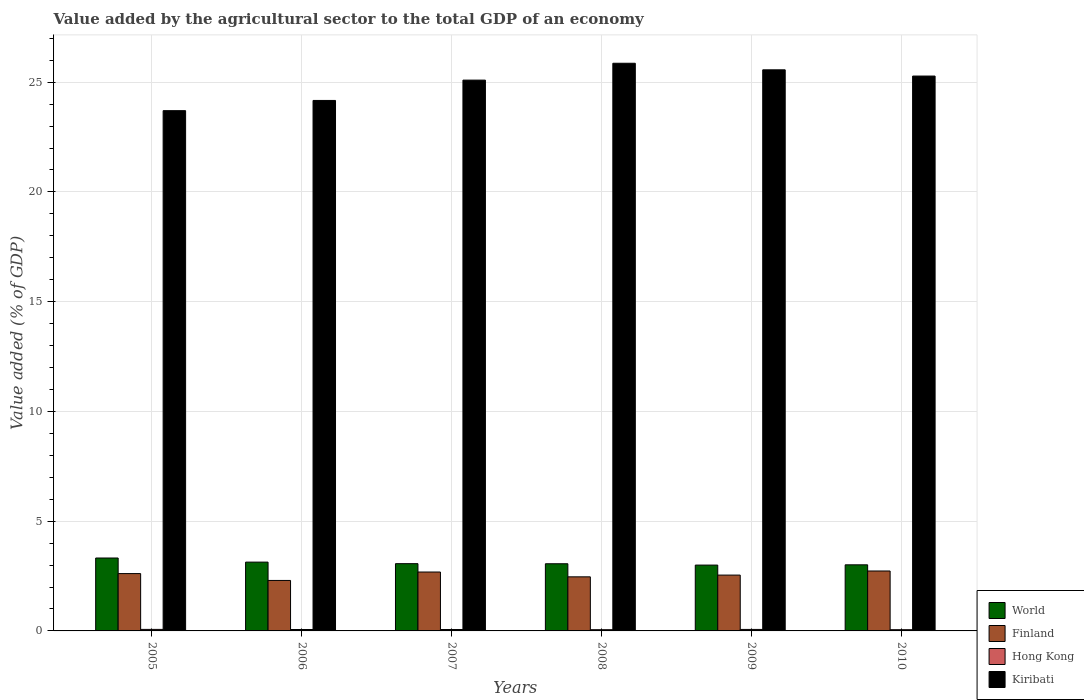How many different coloured bars are there?
Your answer should be very brief. 4. How many groups of bars are there?
Give a very brief answer. 6. Are the number of bars per tick equal to the number of legend labels?
Your answer should be very brief. Yes. Are the number of bars on each tick of the X-axis equal?
Your answer should be very brief. Yes. How many bars are there on the 2nd tick from the right?
Ensure brevity in your answer.  4. What is the label of the 4th group of bars from the left?
Provide a short and direct response. 2008. What is the value added by the agricultural sector to the total GDP in Kiribati in 2006?
Your answer should be compact. 24.17. Across all years, what is the maximum value added by the agricultural sector to the total GDP in Kiribati?
Your response must be concise. 25.86. Across all years, what is the minimum value added by the agricultural sector to the total GDP in Kiribati?
Offer a very short reply. 23.7. In which year was the value added by the agricultural sector to the total GDP in Kiribati minimum?
Provide a short and direct response. 2005. What is the total value added by the agricultural sector to the total GDP in Finland in the graph?
Keep it short and to the point. 15.33. What is the difference between the value added by the agricultural sector to the total GDP in Finland in 2005 and that in 2008?
Provide a short and direct response. 0.15. What is the difference between the value added by the agricultural sector to the total GDP in Finland in 2008 and the value added by the agricultural sector to the total GDP in World in 2007?
Your response must be concise. -0.6. What is the average value added by the agricultural sector to the total GDP in Hong Kong per year?
Offer a terse response. 0.06. In the year 2005, what is the difference between the value added by the agricultural sector to the total GDP in Hong Kong and value added by the agricultural sector to the total GDP in Kiribati?
Offer a very short reply. -23.63. In how many years, is the value added by the agricultural sector to the total GDP in Hong Kong greater than 23 %?
Ensure brevity in your answer.  0. What is the ratio of the value added by the agricultural sector to the total GDP in Kiribati in 2005 to that in 2006?
Your answer should be very brief. 0.98. Is the difference between the value added by the agricultural sector to the total GDP in Hong Kong in 2006 and 2008 greater than the difference between the value added by the agricultural sector to the total GDP in Kiribati in 2006 and 2008?
Make the answer very short. Yes. What is the difference between the highest and the second highest value added by the agricultural sector to the total GDP in Hong Kong?
Your response must be concise. 0. What is the difference between the highest and the lowest value added by the agricultural sector to the total GDP in Kiribati?
Give a very brief answer. 2.16. In how many years, is the value added by the agricultural sector to the total GDP in Hong Kong greater than the average value added by the agricultural sector to the total GDP in Hong Kong taken over all years?
Give a very brief answer. 4. Is the sum of the value added by the agricultural sector to the total GDP in World in 2008 and 2009 greater than the maximum value added by the agricultural sector to the total GDP in Kiribati across all years?
Offer a terse response. No. What does the 3rd bar from the left in 2010 represents?
Give a very brief answer. Hong Kong. What does the 4th bar from the right in 2007 represents?
Provide a short and direct response. World. Are all the bars in the graph horizontal?
Make the answer very short. No. What is the difference between two consecutive major ticks on the Y-axis?
Give a very brief answer. 5. Are the values on the major ticks of Y-axis written in scientific E-notation?
Make the answer very short. No. Does the graph contain grids?
Offer a very short reply. Yes. How are the legend labels stacked?
Offer a very short reply. Vertical. What is the title of the graph?
Your response must be concise. Value added by the agricultural sector to the total GDP of an economy. What is the label or title of the Y-axis?
Your response must be concise. Value added (% of GDP). What is the Value added (% of GDP) of World in 2005?
Keep it short and to the point. 3.32. What is the Value added (% of GDP) in Finland in 2005?
Offer a very short reply. 2.61. What is the Value added (% of GDP) in Hong Kong in 2005?
Offer a terse response. 0.07. What is the Value added (% of GDP) of Kiribati in 2005?
Ensure brevity in your answer.  23.7. What is the Value added (% of GDP) in World in 2006?
Make the answer very short. 3.13. What is the Value added (% of GDP) of Finland in 2006?
Your answer should be very brief. 2.3. What is the Value added (% of GDP) of Hong Kong in 2006?
Provide a short and direct response. 0.06. What is the Value added (% of GDP) of Kiribati in 2006?
Your response must be concise. 24.17. What is the Value added (% of GDP) of World in 2007?
Offer a terse response. 3.06. What is the Value added (% of GDP) in Finland in 2007?
Your response must be concise. 2.68. What is the Value added (% of GDP) of Hong Kong in 2007?
Offer a terse response. 0.06. What is the Value added (% of GDP) of Kiribati in 2007?
Offer a very short reply. 25.09. What is the Value added (% of GDP) of World in 2008?
Make the answer very short. 3.06. What is the Value added (% of GDP) of Finland in 2008?
Your answer should be compact. 2.46. What is the Value added (% of GDP) in Hong Kong in 2008?
Your response must be concise. 0.06. What is the Value added (% of GDP) of Kiribati in 2008?
Give a very brief answer. 25.86. What is the Value added (% of GDP) in World in 2009?
Ensure brevity in your answer.  3. What is the Value added (% of GDP) of Finland in 2009?
Your answer should be compact. 2.54. What is the Value added (% of GDP) in Hong Kong in 2009?
Your response must be concise. 0.07. What is the Value added (% of GDP) of Kiribati in 2009?
Give a very brief answer. 25.56. What is the Value added (% of GDP) of World in 2010?
Offer a very short reply. 3.01. What is the Value added (% of GDP) of Finland in 2010?
Offer a terse response. 2.73. What is the Value added (% of GDP) of Hong Kong in 2010?
Make the answer very short. 0.06. What is the Value added (% of GDP) in Kiribati in 2010?
Your response must be concise. 25.28. Across all years, what is the maximum Value added (% of GDP) of World?
Make the answer very short. 3.32. Across all years, what is the maximum Value added (% of GDP) in Finland?
Offer a terse response. 2.73. Across all years, what is the maximum Value added (% of GDP) in Hong Kong?
Give a very brief answer. 0.07. Across all years, what is the maximum Value added (% of GDP) in Kiribati?
Provide a short and direct response. 25.86. Across all years, what is the minimum Value added (% of GDP) of World?
Make the answer very short. 3. Across all years, what is the minimum Value added (% of GDP) of Finland?
Offer a very short reply. 2.3. Across all years, what is the minimum Value added (% of GDP) in Hong Kong?
Keep it short and to the point. 0.06. Across all years, what is the minimum Value added (% of GDP) of Kiribati?
Offer a terse response. 23.7. What is the total Value added (% of GDP) in World in the graph?
Provide a short and direct response. 18.59. What is the total Value added (% of GDP) of Finland in the graph?
Your answer should be compact. 15.33. What is the total Value added (% of GDP) of Hong Kong in the graph?
Make the answer very short. 0.38. What is the total Value added (% of GDP) in Kiribati in the graph?
Provide a short and direct response. 149.67. What is the difference between the Value added (% of GDP) of World in 2005 and that in 2006?
Offer a very short reply. 0.19. What is the difference between the Value added (% of GDP) of Finland in 2005 and that in 2006?
Ensure brevity in your answer.  0.31. What is the difference between the Value added (% of GDP) of Hong Kong in 2005 and that in 2006?
Make the answer very short. 0. What is the difference between the Value added (% of GDP) in Kiribati in 2005 and that in 2006?
Your answer should be compact. -0.47. What is the difference between the Value added (% of GDP) in World in 2005 and that in 2007?
Your answer should be very brief. 0.26. What is the difference between the Value added (% of GDP) of Finland in 2005 and that in 2007?
Ensure brevity in your answer.  -0.07. What is the difference between the Value added (% of GDP) in Hong Kong in 2005 and that in 2007?
Your answer should be compact. 0.01. What is the difference between the Value added (% of GDP) in Kiribati in 2005 and that in 2007?
Provide a short and direct response. -1.39. What is the difference between the Value added (% of GDP) of World in 2005 and that in 2008?
Your answer should be very brief. 0.26. What is the difference between the Value added (% of GDP) in Finland in 2005 and that in 2008?
Make the answer very short. 0.15. What is the difference between the Value added (% of GDP) of Hong Kong in 2005 and that in 2008?
Make the answer very short. 0.01. What is the difference between the Value added (% of GDP) of Kiribati in 2005 and that in 2008?
Offer a very short reply. -2.16. What is the difference between the Value added (% of GDP) of World in 2005 and that in 2009?
Give a very brief answer. 0.32. What is the difference between the Value added (% of GDP) of Finland in 2005 and that in 2009?
Provide a short and direct response. 0.07. What is the difference between the Value added (% of GDP) in Hong Kong in 2005 and that in 2009?
Provide a succinct answer. 0. What is the difference between the Value added (% of GDP) in Kiribati in 2005 and that in 2009?
Offer a very short reply. -1.86. What is the difference between the Value added (% of GDP) of World in 2005 and that in 2010?
Make the answer very short. 0.31. What is the difference between the Value added (% of GDP) of Finland in 2005 and that in 2010?
Your response must be concise. -0.12. What is the difference between the Value added (% of GDP) in Hong Kong in 2005 and that in 2010?
Offer a very short reply. 0.01. What is the difference between the Value added (% of GDP) in Kiribati in 2005 and that in 2010?
Give a very brief answer. -1.58. What is the difference between the Value added (% of GDP) in World in 2006 and that in 2007?
Offer a terse response. 0.07. What is the difference between the Value added (% of GDP) of Finland in 2006 and that in 2007?
Keep it short and to the point. -0.38. What is the difference between the Value added (% of GDP) of Hong Kong in 2006 and that in 2007?
Keep it short and to the point. 0. What is the difference between the Value added (% of GDP) in Kiribati in 2006 and that in 2007?
Give a very brief answer. -0.93. What is the difference between the Value added (% of GDP) of World in 2006 and that in 2008?
Your response must be concise. 0.07. What is the difference between the Value added (% of GDP) in Finland in 2006 and that in 2008?
Provide a short and direct response. -0.16. What is the difference between the Value added (% of GDP) in Hong Kong in 2006 and that in 2008?
Your response must be concise. 0.01. What is the difference between the Value added (% of GDP) of Kiribati in 2006 and that in 2008?
Your answer should be compact. -1.69. What is the difference between the Value added (% of GDP) in World in 2006 and that in 2009?
Make the answer very short. 0.14. What is the difference between the Value added (% of GDP) of Finland in 2006 and that in 2009?
Your answer should be compact. -0.24. What is the difference between the Value added (% of GDP) of Hong Kong in 2006 and that in 2009?
Make the answer very short. -0. What is the difference between the Value added (% of GDP) of Kiribati in 2006 and that in 2009?
Your answer should be compact. -1.4. What is the difference between the Value added (% of GDP) of World in 2006 and that in 2010?
Provide a short and direct response. 0.12. What is the difference between the Value added (% of GDP) of Finland in 2006 and that in 2010?
Offer a terse response. -0.43. What is the difference between the Value added (% of GDP) in Hong Kong in 2006 and that in 2010?
Offer a very short reply. 0.01. What is the difference between the Value added (% of GDP) in Kiribati in 2006 and that in 2010?
Offer a terse response. -1.11. What is the difference between the Value added (% of GDP) of World in 2007 and that in 2008?
Your answer should be compact. 0. What is the difference between the Value added (% of GDP) in Finland in 2007 and that in 2008?
Make the answer very short. 0.22. What is the difference between the Value added (% of GDP) in Hong Kong in 2007 and that in 2008?
Ensure brevity in your answer.  0.01. What is the difference between the Value added (% of GDP) of Kiribati in 2007 and that in 2008?
Offer a terse response. -0.77. What is the difference between the Value added (% of GDP) of World in 2007 and that in 2009?
Offer a very short reply. 0.06. What is the difference between the Value added (% of GDP) in Finland in 2007 and that in 2009?
Offer a terse response. 0.14. What is the difference between the Value added (% of GDP) in Hong Kong in 2007 and that in 2009?
Your answer should be compact. -0. What is the difference between the Value added (% of GDP) in Kiribati in 2007 and that in 2009?
Offer a very short reply. -0.47. What is the difference between the Value added (% of GDP) in World in 2007 and that in 2010?
Offer a terse response. 0.05. What is the difference between the Value added (% of GDP) in Finland in 2007 and that in 2010?
Ensure brevity in your answer.  -0.05. What is the difference between the Value added (% of GDP) of Hong Kong in 2007 and that in 2010?
Offer a very short reply. 0.01. What is the difference between the Value added (% of GDP) of Kiribati in 2007 and that in 2010?
Keep it short and to the point. -0.19. What is the difference between the Value added (% of GDP) in World in 2008 and that in 2009?
Give a very brief answer. 0.06. What is the difference between the Value added (% of GDP) of Finland in 2008 and that in 2009?
Ensure brevity in your answer.  -0.08. What is the difference between the Value added (% of GDP) in Hong Kong in 2008 and that in 2009?
Make the answer very short. -0.01. What is the difference between the Value added (% of GDP) in Kiribati in 2008 and that in 2009?
Provide a succinct answer. 0.3. What is the difference between the Value added (% of GDP) of World in 2008 and that in 2010?
Your answer should be very brief. 0.05. What is the difference between the Value added (% of GDP) of Finland in 2008 and that in 2010?
Make the answer very short. -0.27. What is the difference between the Value added (% of GDP) in Hong Kong in 2008 and that in 2010?
Make the answer very short. 0. What is the difference between the Value added (% of GDP) in Kiribati in 2008 and that in 2010?
Offer a very short reply. 0.58. What is the difference between the Value added (% of GDP) of World in 2009 and that in 2010?
Keep it short and to the point. -0.01. What is the difference between the Value added (% of GDP) in Finland in 2009 and that in 2010?
Provide a short and direct response. -0.19. What is the difference between the Value added (% of GDP) in Hong Kong in 2009 and that in 2010?
Keep it short and to the point. 0.01. What is the difference between the Value added (% of GDP) of Kiribati in 2009 and that in 2010?
Keep it short and to the point. 0.28. What is the difference between the Value added (% of GDP) of World in 2005 and the Value added (% of GDP) of Finland in 2006?
Provide a succinct answer. 1.02. What is the difference between the Value added (% of GDP) of World in 2005 and the Value added (% of GDP) of Hong Kong in 2006?
Give a very brief answer. 3.26. What is the difference between the Value added (% of GDP) in World in 2005 and the Value added (% of GDP) in Kiribati in 2006?
Your answer should be compact. -20.85. What is the difference between the Value added (% of GDP) of Finland in 2005 and the Value added (% of GDP) of Hong Kong in 2006?
Provide a succinct answer. 2.55. What is the difference between the Value added (% of GDP) of Finland in 2005 and the Value added (% of GDP) of Kiribati in 2006?
Your answer should be very brief. -21.56. What is the difference between the Value added (% of GDP) in Hong Kong in 2005 and the Value added (% of GDP) in Kiribati in 2006?
Your answer should be compact. -24.1. What is the difference between the Value added (% of GDP) of World in 2005 and the Value added (% of GDP) of Finland in 2007?
Your response must be concise. 0.64. What is the difference between the Value added (% of GDP) in World in 2005 and the Value added (% of GDP) in Hong Kong in 2007?
Offer a very short reply. 3.26. What is the difference between the Value added (% of GDP) in World in 2005 and the Value added (% of GDP) in Kiribati in 2007?
Make the answer very short. -21.77. What is the difference between the Value added (% of GDP) in Finland in 2005 and the Value added (% of GDP) in Hong Kong in 2007?
Give a very brief answer. 2.55. What is the difference between the Value added (% of GDP) of Finland in 2005 and the Value added (% of GDP) of Kiribati in 2007?
Make the answer very short. -22.48. What is the difference between the Value added (% of GDP) in Hong Kong in 2005 and the Value added (% of GDP) in Kiribati in 2007?
Keep it short and to the point. -25.03. What is the difference between the Value added (% of GDP) in World in 2005 and the Value added (% of GDP) in Finland in 2008?
Offer a very short reply. 0.86. What is the difference between the Value added (% of GDP) of World in 2005 and the Value added (% of GDP) of Hong Kong in 2008?
Provide a succinct answer. 3.27. What is the difference between the Value added (% of GDP) in World in 2005 and the Value added (% of GDP) in Kiribati in 2008?
Provide a short and direct response. -22.54. What is the difference between the Value added (% of GDP) in Finland in 2005 and the Value added (% of GDP) in Hong Kong in 2008?
Keep it short and to the point. 2.56. What is the difference between the Value added (% of GDP) in Finland in 2005 and the Value added (% of GDP) in Kiribati in 2008?
Make the answer very short. -23.25. What is the difference between the Value added (% of GDP) in Hong Kong in 2005 and the Value added (% of GDP) in Kiribati in 2008?
Your answer should be very brief. -25.79. What is the difference between the Value added (% of GDP) of World in 2005 and the Value added (% of GDP) of Finland in 2009?
Keep it short and to the point. 0.78. What is the difference between the Value added (% of GDP) of World in 2005 and the Value added (% of GDP) of Hong Kong in 2009?
Keep it short and to the point. 3.25. What is the difference between the Value added (% of GDP) of World in 2005 and the Value added (% of GDP) of Kiribati in 2009?
Offer a very short reply. -22.24. What is the difference between the Value added (% of GDP) of Finland in 2005 and the Value added (% of GDP) of Hong Kong in 2009?
Offer a very short reply. 2.54. What is the difference between the Value added (% of GDP) of Finland in 2005 and the Value added (% of GDP) of Kiribati in 2009?
Provide a succinct answer. -22.95. What is the difference between the Value added (% of GDP) in Hong Kong in 2005 and the Value added (% of GDP) in Kiribati in 2009?
Make the answer very short. -25.49. What is the difference between the Value added (% of GDP) in World in 2005 and the Value added (% of GDP) in Finland in 2010?
Offer a very short reply. 0.59. What is the difference between the Value added (% of GDP) in World in 2005 and the Value added (% of GDP) in Hong Kong in 2010?
Ensure brevity in your answer.  3.27. What is the difference between the Value added (% of GDP) in World in 2005 and the Value added (% of GDP) in Kiribati in 2010?
Provide a succinct answer. -21.96. What is the difference between the Value added (% of GDP) in Finland in 2005 and the Value added (% of GDP) in Hong Kong in 2010?
Provide a short and direct response. 2.56. What is the difference between the Value added (% of GDP) in Finland in 2005 and the Value added (% of GDP) in Kiribati in 2010?
Your response must be concise. -22.67. What is the difference between the Value added (% of GDP) of Hong Kong in 2005 and the Value added (% of GDP) of Kiribati in 2010?
Provide a succinct answer. -25.21. What is the difference between the Value added (% of GDP) of World in 2006 and the Value added (% of GDP) of Finland in 2007?
Your answer should be very brief. 0.45. What is the difference between the Value added (% of GDP) in World in 2006 and the Value added (% of GDP) in Hong Kong in 2007?
Give a very brief answer. 3.07. What is the difference between the Value added (% of GDP) in World in 2006 and the Value added (% of GDP) in Kiribati in 2007?
Your response must be concise. -21.96. What is the difference between the Value added (% of GDP) of Finland in 2006 and the Value added (% of GDP) of Hong Kong in 2007?
Your response must be concise. 2.24. What is the difference between the Value added (% of GDP) in Finland in 2006 and the Value added (% of GDP) in Kiribati in 2007?
Keep it short and to the point. -22.8. What is the difference between the Value added (% of GDP) of Hong Kong in 2006 and the Value added (% of GDP) of Kiribati in 2007?
Give a very brief answer. -25.03. What is the difference between the Value added (% of GDP) of World in 2006 and the Value added (% of GDP) of Finland in 2008?
Offer a very short reply. 0.67. What is the difference between the Value added (% of GDP) of World in 2006 and the Value added (% of GDP) of Hong Kong in 2008?
Your answer should be very brief. 3.08. What is the difference between the Value added (% of GDP) in World in 2006 and the Value added (% of GDP) in Kiribati in 2008?
Ensure brevity in your answer.  -22.73. What is the difference between the Value added (% of GDP) in Finland in 2006 and the Value added (% of GDP) in Hong Kong in 2008?
Make the answer very short. 2.24. What is the difference between the Value added (% of GDP) of Finland in 2006 and the Value added (% of GDP) of Kiribati in 2008?
Provide a short and direct response. -23.56. What is the difference between the Value added (% of GDP) in Hong Kong in 2006 and the Value added (% of GDP) in Kiribati in 2008?
Give a very brief answer. -25.8. What is the difference between the Value added (% of GDP) in World in 2006 and the Value added (% of GDP) in Finland in 2009?
Your answer should be compact. 0.59. What is the difference between the Value added (% of GDP) of World in 2006 and the Value added (% of GDP) of Hong Kong in 2009?
Offer a very short reply. 3.07. What is the difference between the Value added (% of GDP) of World in 2006 and the Value added (% of GDP) of Kiribati in 2009?
Your answer should be compact. -22.43. What is the difference between the Value added (% of GDP) of Finland in 2006 and the Value added (% of GDP) of Hong Kong in 2009?
Your response must be concise. 2.23. What is the difference between the Value added (% of GDP) in Finland in 2006 and the Value added (% of GDP) in Kiribati in 2009?
Keep it short and to the point. -23.26. What is the difference between the Value added (% of GDP) in Hong Kong in 2006 and the Value added (% of GDP) in Kiribati in 2009?
Provide a short and direct response. -25.5. What is the difference between the Value added (% of GDP) in World in 2006 and the Value added (% of GDP) in Finland in 2010?
Provide a short and direct response. 0.4. What is the difference between the Value added (% of GDP) of World in 2006 and the Value added (% of GDP) of Hong Kong in 2010?
Offer a very short reply. 3.08. What is the difference between the Value added (% of GDP) in World in 2006 and the Value added (% of GDP) in Kiribati in 2010?
Your answer should be compact. -22.14. What is the difference between the Value added (% of GDP) of Finland in 2006 and the Value added (% of GDP) of Hong Kong in 2010?
Your response must be concise. 2.24. What is the difference between the Value added (% of GDP) in Finland in 2006 and the Value added (% of GDP) in Kiribati in 2010?
Keep it short and to the point. -22.98. What is the difference between the Value added (% of GDP) in Hong Kong in 2006 and the Value added (% of GDP) in Kiribati in 2010?
Ensure brevity in your answer.  -25.22. What is the difference between the Value added (% of GDP) in World in 2007 and the Value added (% of GDP) in Finland in 2008?
Give a very brief answer. 0.6. What is the difference between the Value added (% of GDP) in World in 2007 and the Value added (% of GDP) in Hong Kong in 2008?
Offer a terse response. 3.01. What is the difference between the Value added (% of GDP) in World in 2007 and the Value added (% of GDP) in Kiribati in 2008?
Ensure brevity in your answer.  -22.8. What is the difference between the Value added (% of GDP) of Finland in 2007 and the Value added (% of GDP) of Hong Kong in 2008?
Provide a short and direct response. 2.63. What is the difference between the Value added (% of GDP) of Finland in 2007 and the Value added (% of GDP) of Kiribati in 2008?
Make the answer very short. -23.18. What is the difference between the Value added (% of GDP) in Hong Kong in 2007 and the Value added (% of GDP) in Kiribati in 2008?
Offer a very short reply. -25.8. What is the difference between the Value added (% of GDP) in World in 2007 and the Value added (% of GDP) in Finland in 2009?
Give a very brief answer. 0.52. What is the difference between the Value added (% of GDP) in World in 2007 and the Value added (% of GDP) in Hong Kong in 2009?
Your answer should be compact. 3. What is the difference between the Value added (% of GDP) of World in 2007 and the Value added (% of GDP) of Kiribati in 2009?
Your answer should be very brief. -22.5. What is the difference between the Value added (% of GDP) in Finland in 2007 and the Value added (% of GDP) in Hong Kong in 2009?
Make the answer very short. 2.62. What is the difference between the Value added (% of GDP) in Finland in 2007 and the Value added (% of GDP) in Kiribati in 2009?
Offer a terse response. -22.88. What is the difference between the Value added (% of GDP) of Hong Kong in 2007 and the Value added (% of GDP) of Kiribati in 2009?
Give a very brief answer. -25.5. What is the difference between the Value added (% of GDP) of World in 2007 and the Value added (% of GDP) of Finland in 2010?
Your answer should be compact. 0.33. What is the difference between the Value added (% of GDP) of World in 2007 and the Value added (% of GDP) of Hong Kong in 2010?
Keep it short and to the point. 3.01. What is the difference between the Value added (% of GDP) of World in 2007 and the Value added (% of GDP) of Kiribati in 2010?
Provide a short and direct response. -22.22. What is the difference between the Value added (% of GDP) of Finland in 2007 and the Value added (% of GDP) of Hong Kong in 2010?
Provide a short and direct response. 2.63. What is the difference between the Value added (% of GDP) in Finland in 2007 and the Value added (% of GDP) in Kiribati in 2010?
Give a very brief answer. -22.6. What is the difference between the Value added (% of GDP) in Hong Kong in 2007 and the Value added (% of GDP) in Kiribati in 2010?
Your answer should be compact. -25.22. What is the difference between the Value added (% of GDP) in World in 2008 and the Value added (% of GDP) in Finland in 2009?
Offer a very short reply. 0.52. What is the difference between the Value added (% of GDP) of World in 2008 and the Value added (% of GDP) of Hong Kong in 2009?
Your answer should be compact. 2.99. What is the difference between the Value added (% of GDP) of World in 2008 and the Value added (% of GDP) of Kiribati in 2009?
Offer a terse response. -22.5. What is the difference between the Value added (% of GDP) of Finland in 2008 and the Value added (% of GDP) of Hong Kong in 2009?
Offer a terse response. 2.4. What is the difference between the Value added (% of GDP) of Finland in 2008 and the Value added (% of GDP) of Kiribati in 2009?
Your answer should be compact. -23.1. What is the difference between the Value added (% of GDP) in Hong Kong in 2008 and the Value added (% of GDP) in Kiribati in 2009?
Ensure brevity in your answer.  -25.51. What is the difference between the Value added (% of GDP) of World in 2008 and the Value added (% of GDP) of Finland in 2010?
Your response must be concise. 0.33. What is the difference between the Value added (% of GDP) of World in 2008 and the Value added (% of GDP) of Hong Kong in 2010?
Provide a succinct answer. 3. What is the difference between the Value added (% of GDP) in World in 2008 and the Value added (% of GDP) in Kiribati in 2010?
Keep it short and to the point. -22.22. What is the difference between the Value added (% of GDP) of Finland in 2008 and the Value added (% of GDP) of Hong Kong in 2010?
Your answer should be very brief. 2.41. What is the difference between the Value added (% of GDP) of Finland in 2008 and the Value added (% of GDP) of Kiribati in 2010?
Your answer should be very brief. -22.82. What is the difference between the Value added (% of GDP) of Hong Kong in 2008 and the Value added (% of GDP) of Kiribati in 2010?
Ensure brevity in your answer.  -25.22. What is the difference between the Value added (% of GDP) of World in 2009 and the Value added (% of GDP) of Finland in 2010?
Your answer should be very brief. 0.27. What is the difference between the Value added (% of GDP) in World in 2009 and the Value added (% of GDP) in Hong Kong in 2010?
Offer a terse response. 2.94. What is the difference between the Value added (% of GDP) in World in 2009 and the Value added (% of GDP) in Kiribati in 2010?
Your answer should be very brief. -22.28. What is the difference between the Value added (% of GDP) in Finland in 2009 and the Value added (% of GDP) in Hong Kong in 2010?
Offer a very short reply. 2.49. What is the difference between the Value added (% of GDP) of Finland in 2009 and the Value added (% of GDP) of Kiribati in 2010?
Provide a short and direct response. -22.74. What is the difference between the Value added (% of GDP) of Hong Kong in 2009 and the Value added (% of GDP) of Kiribati in 2010?
Ensure brevity in your answer.  -25.21. What is the average Value added (% of GDP) of World per year?
Your response must be concise. 3.1. What is the average Value added (% of GDP) of Finland per year?
Provide a short and direct response. 2.56. What is the average Value added (% of GDP) of Hong Kong per year?
Ensure brevity in your answer.  0.06. What is the average Value added (% of GDP) of Kiribati per year?
Offer a very short reply. 24.95. In the year 2005, what is the difference between the Value added (% of GDP) of World and Value added (% of GDP) of Finland?
Your answer should be compact. 0.71. In the year 2005, what is the difference between the Value added (% of GDP) in World and Value added (% of GDP) in Hong Kong?
Offer a very short reply. 3.25. In the year 2005, what is the difference between the Value added (% of GDP) of World and Value added (% of GDP) of Kiribati?
Ensure brevity in your answer.  -20.38. In the year 2005, what is the difference between the Value added (% of GDP) of Finland and Value added (% of GDP) of Hong Kong?
Your response must be concise. 2.54. In the year 2005, what is the difference between the Value added (% of GDP) of Finland and Value added (% of GDP) of Kiribati?
Make the answer very short. -21.09. In the year 2005, what is the difference between the Value added (% of GDP) in Hong Kong and Value added (% of GDP) in Kiribati?
Give a very brief answer. -23.63. In the year 2006, what is the difference between the Value added (% of GDP) in World and Value added (% of GDP) in Finland?
Your answer should be compact. 0.84. In the year 2006, what is the difference between the Value added (% of GDP) of World and Value added (% of GDP) of Hong Kong?
Your response must be concise. 3.07. In the year 2006, what is the difference between the Value added (% of GDP) of World and Value added (% of GDP) of Kiribati?
Provide a succinct answer. -21.03. In the year 2006, what is the difference between the Value added (% of GDP) of Finland and Value added (% of GDP) of Hong Kong?
Your answer should be compact. 2.23. In the year 2006, what is the difference between the Value added (% of GDP) of Finland and Value added (% of GDP) of Kiribati?
Your answer should be very brief. -21.87. In the year 2006, what is the difference between the Value added (% of GDP) in Hong Kong and Value added (% of GDP) in Kiribati?
Offer a very short reply. -24.1. In the year 2007, what is the difference between the Value added (% of GDP) in World and Value added (% of GDP) in Finland?
Provide a succinct answer. 0.38. In the year 2007, what is the difference between the Value added (% of GDP) of World and Value added (% of GDP) of Hong Kong?
Your answer should be compact. 3. In the year 2007, what is the difference between the Value added (% of GDP) in World and Value added (% of GDP) in Kiribati?
Give a very brief answer. -22.03. In the year 2007, what is the difference between the Value added (% of GDP) of Finland and Value added (% of GDP) of Hong Kong?
Your response must be concise. 2.62. In the year 2007, what is the difference between the Value added (% of GDP) of Finland and Value added (% of GDP) of Kiribati?
Offer a very short reply. -22.41. In the year 2007, what is the difference between the Value added (% of GDP) in Hong Kong and Value added (% of GDP) in Kiribati?
Keep it short and to the point. -25.03. In the year 2008, what is the difference between the Value added (% of GDP) in World and Value added (% of GDP) in Finland?
Offer a very short reply. 0.6. In the year 2008, what is the difference between the Value added (% of GDP) in World and Value added (% of GDP) in Hong Kong?
Your answer should be very brief. 3. In the year 2008, what is the difference between the Value added (% of GDP) of World and Value added (% of GDP) of Kiribati?
Provide a succinct answer. -22.8. In the year 2008, what is the difference between the Value added (% of GDP) of Finland and Value added (% of GDP) of Hong Kong?
Keep it short and to the point. 2.41. In the year 2008, what is the difference between the Value added (% of GDP) in Finland and Value added (% of GDP) in Kiribati?
Offer a very short reply. -23.4. In the year 2008, what is the difference between the Value added (% of GDP) in Hong Kong and Value added (% of GDP) in Kiribati?
Offer a very short reply. -25.81. In the year 2009, what is the difference between the Value added (% of GDP) in World and Value added (% of GDP) in Finland?
Your response must be concise. 0.46. In the year 2009, what is the difference between the Value added (% of GDP) in World and Value added (% of GDP) in Hong Kong?
Offer a very short reply. 2.93. In the year 2009, what is the difference between the Value added (% of GDP) in World and Value added (% of GDP) in Kiribati?
Give a very brief answer. -22.56. In the year 2009, what is the difference between the Value added (% of GDP) in Finland and Value added (% of GDP) in Hong Kong?
Your response must be concise. 2.48. In the year 2009, what is the difference between the Value added (% of GDP) in Finland and Value added (% of GDP) in Kiribati?
Provide a succinct answer. -23.02. In the year 2009, what is the difference between the Value added (% of GDP) of Hong Kong and Value added (% of GDP) of Kiribati?
Make the answer very short. -25.5. In the year 2010, what is the difference between the Value added (% of GDP) in World and Value added (% of GDP) in Finland?
Provide a short and direct response. 0.28. In the year 2010, what is the difference between the Value added (% of GDP) in World and Value added (% of GDP) in Hong Kong?
Your answer should be compact. 2.96. In the year 2010, what is the difference between the Value added (% of GDP) in World and Value added (% of GDP) in Kiribati?
Your answer should be very brief. -22.27. In the year 2010, what is the difference between the Value added (% of GDP) of Finland and Value added (% of GDP) of Hong Kong?
Provide a short and direct response. 2.68. In the year 2010, what is the difference between the Value added (% of GDP) in Finland and Value added (% of GDP) in Kiribati?
Ensure brevity in your answer.  -22.55. In the year 2010, what is the difference between the Value added (% of GDP) in Hong Kong and Value added (% of GDP) in Kiribati?
Keep it short and to the point. -25.22. What is the ratio of the Value added (% of GDP) in World in 2005 to that in 2006?
Keep it short and to the point. 1.06. What is the ratio of the Value added (% of GDP) of Finland in 2005 to that in 2006?
Offer a terse response. 1.14. What is the ratio of the Value added (% of GDP) in Hong Kong in 2005 to that in 2006?
Offer a terse response. 1.07. What is the ratio of the Value added (% of GDP) in Kiribati in 2005 to that in 2006?
Your answer should be very brief. 0.98. What is the ratio of the Value added (% of GDP) in World in 2005 to that in 2007?
Your answer should be very brief. 1.08. What is the ratio of the Value added (% of GDP) in Finland in 2005 to that in 2007?
Give a very brief answer. 0.97. What is the ratio of the Value added (% of GDP) in Hong Kong in 2005 to that in 2007?
Make the answer very short. 1.08. What is the ratio of the Value added (% of GDP) of Kiribati in 2005 to that in 2007?
Provide a succinct answer. 0.94. What is the ratio of the Value added (% of GDP) in World in 2005 to that in 2008?
Your response must be concise. 1.09. What is the ratio of the Value added (% of GDP) of Finland in 2005 to that in 2008?
Offer a very short reply. 1.06. What is the ratio of the Value added (% of GDP) of Hong Kong in 2005 to that in 2008?
Provide a succinct answer. 1.23. What is the ratio of the Value added (% of GDP) of Kiribati in 2005 to that in 2008?
Make the answer very short. 0.92. What is the ratio of the Value added (% of GDP) of World in 2005 to that in 2009?
Ensure brevity in your answer.  1.11. What is the ratio of the Value added (% of GDP) of Hong Kong in 2005 to that in 2009?
Offer a very short reply. 1.02. What is the ratio of the Value added (% of GDP) in Kiribati in 2005 to that in 2009?
Provide a succinct answer. 0.93. What is the ratio of the Value added (% of GDP) of World in 2005 to that in 2010?
Your answer should be very brief. 1.1. What is the ratio of the Value added (% of GDP) of Finland in 2005 to that in 2010?
Keep it short and to the point. 0.96. What is the ratio of the Value added (% of GDP) of Hong Kong in 2005 to that in 2010?
Offer a terse response. 1.25. What is the ratio of the Value added (% of GDP) in Kiribati in 2005 to that in 2010?
Your response must be concise. 0.94. What is the ratio of the Value added (% of GDP) in World in 2006 to that in 2007?
Your response must be concise. 1.02. What is the ratio of the Value added (% of GDP) of Finland in 2006 to that in 2007?
Offer a very short reply. 0.86. What is the ratio of the Value added (% of GDP) in Hong Kong in 2006 to that in 2007?
Keep it short and to the point. 1.01. What is the ratio of the Value added (% of GDP) of Kiribati in 2006 to that in 2007?
Your answer should be compact. 0.96. What is the ratio of the Value added (% of GDP) in World in 2006 to that in 2008?
Your answer should be compact. 1.02. What is the ratio of the Value added (% of GDP) in Finland in 2006 to that in 2008?
Offer a terse response. 0.93. What is the ratio of the Value added (% of GDP) of Hong Kong in 2006 to that in 2008?
Offer a very short reply. 1.15. What is the ratio of the Value added (% of GDP) in Kiribati in 2006 to that in 2008?
Your response must be concise. 0.93. What is the ratio of the Value added (% of GDP) in World in 2006 to that in 2009?
Your answer should be very brief. 1.05. What is the ratio of the Value added (% of GDP) of Finland in 2006 to that in 2009?
Provide a succinct answer. 0.9. What is the ratio of the Value added (% of GDP) of Hong Kong in 2006 to that in 2009?
Make the answer very short. 0.95. What is the ratio of the Value added (% of GDP) in Kiribati in 2006 to that in 2009?
Your answer should be compact. 0.95. What is the ratio of the Value added (% of GDP) of World in 2006 to that in 2010?
Your answer should be compact. 1.04. What is the ratio of the Value added (% of GDP) in Finland in 2006 to that in 2010?
Make the answer very short. 0.84. What is the ratio of the Value added (% of GDP) in Hong Kong in 2006 to that in 2010?
Give a very brief answer. 1.17. What is the ratio of the Value added (% of GDP) of Kiribati in 2006 to that in 2010?
Provide a succinct answer. 0.96. What is the ratio of the Value added (% of GDP) in Finland in 2007 to that in 2008?
Provide a succinct answer. 1.09. What is the ratio of the Value added (% of GDP) in Hong Kong in 2007 to that in 2008?
Offer a terse response. 1.14. What is the ratio of the Value added (% of GDP) in Kiribati in 2007 to that in 2008?
Keep it short and to the point. 0.97. What is the ratio of the Value added (% of GDP) of World in 2007 to that in 2009?
Ensure brevity in your answer.  1.02. What is the ratio of the Value added (% of GDP) of Finland in 2007 to that in 2009?
Make the answer very short. 1.05. What is the ratio of the Value added (% of GDP) in Hong Kong in 2007 to that in 2009?
Offer a very short reply. 0.94. What is the ratio of the Value added (% of GDP) in Kiribati in 2007 to that in 2009?
Your answer should be compact. 0.98. What is the ratio of the Value added (% of GDP) of World in 2007 to that in 2010?
Offer a very short reply. 1.02. What is the ratio of the Value added (% of GDP) of Finland in 2007 to that in 2010?
Make the answer very short. 0.98. What is the ratio of the Value added (% of GDP) in Hong Kong in 2007 to that in 2010?
Your response must be concise. 1.15. What is the ratio of the Value added (% of GDP) in Kiribati in 2007 to that in 2010?
Make the answer very short. 0.99. What is the ratio of the Value added (% of GDP) in World in 2008 to that in 2009?
Ensure brevity in your answer.  1.02. What is the ratio of the Value added (% of GDP) in Finland in 2008 to that in 2009?
Your response must be concise. 0.97. What is the ratio of the Value added (% of GDP) of Hong Kong in 2008 to that in 2009?
Offer a very short reply. 0.83. What is the ratio of the Value added (% of GDP) of Kiribati in 2008 to that in 2009?
Give a very brief answer. 1.01. What is the ratio of the Value added (% of GDP) in World in 2008 to that in 2010?
Make the answer very short. 1.02. What is the ratio of the Value added (% of GDP) in Finland in 2008 to that in 2010?
Provide a short and direct response. 0.9. What is the ratio of the Value added (% of GDP) of Hong Kong in 2008 to that in 2010?
Offer a very short reply. 1.01. What is the ratio of the Value added (% of GDP) of Kiribati in 2008 to that in 2010?
Give a very brief answer. 1.02. What is the ratio of the Value added (% of GDP) in World in 2009 to that in 2010?
Keep it short and to the point. 1. What is the ratio of the Value added (% of GDP) of Finland in 2009 to that in 2010?
Your answer should be very brief. 0.93. What is the ratio of the Value added (% of GDP) in Hong Kong in 2009 to that in 2010?
Keep it short and to the point. 1.22. What is the ratio of the Value added (% of GDP) of Kiribati in 2009 to that in 2010?
Give a very brief answer. 1.01. What is the difference between the highest and the second highest Value added (% of GDP) of World?
Your response must be concise. 0.19. What is the difference between the highest and the second highest Value added (% of GDP) of Finland?
Ensure brevity in your answer.  0.05. What is the difference between the highest and the second highest Value added (% of GDP) of Hong Kong?
Your response must be concise. 0. What is the difference between the highest and the second highest Value added (% of GDP) of Kiribati?
Your response must be concise. 0.3. What is the difference between the highest and the lowest Value added (% of GDP) of World?
Offer a terse response. 0.32. What is the difference between the highest and the lowest Value added (% of GDP) in Finland?
Ensure brevity in your answer.  0.43. What is the difference between the highest and the lowest Value added (% of GDP) in Hong Kong?
Offer a very short reply. 0.01. What is the difference between the highest and the lowest Value added (% of GDP) of Kiribati?
Offer a very short reply. 2.16. 